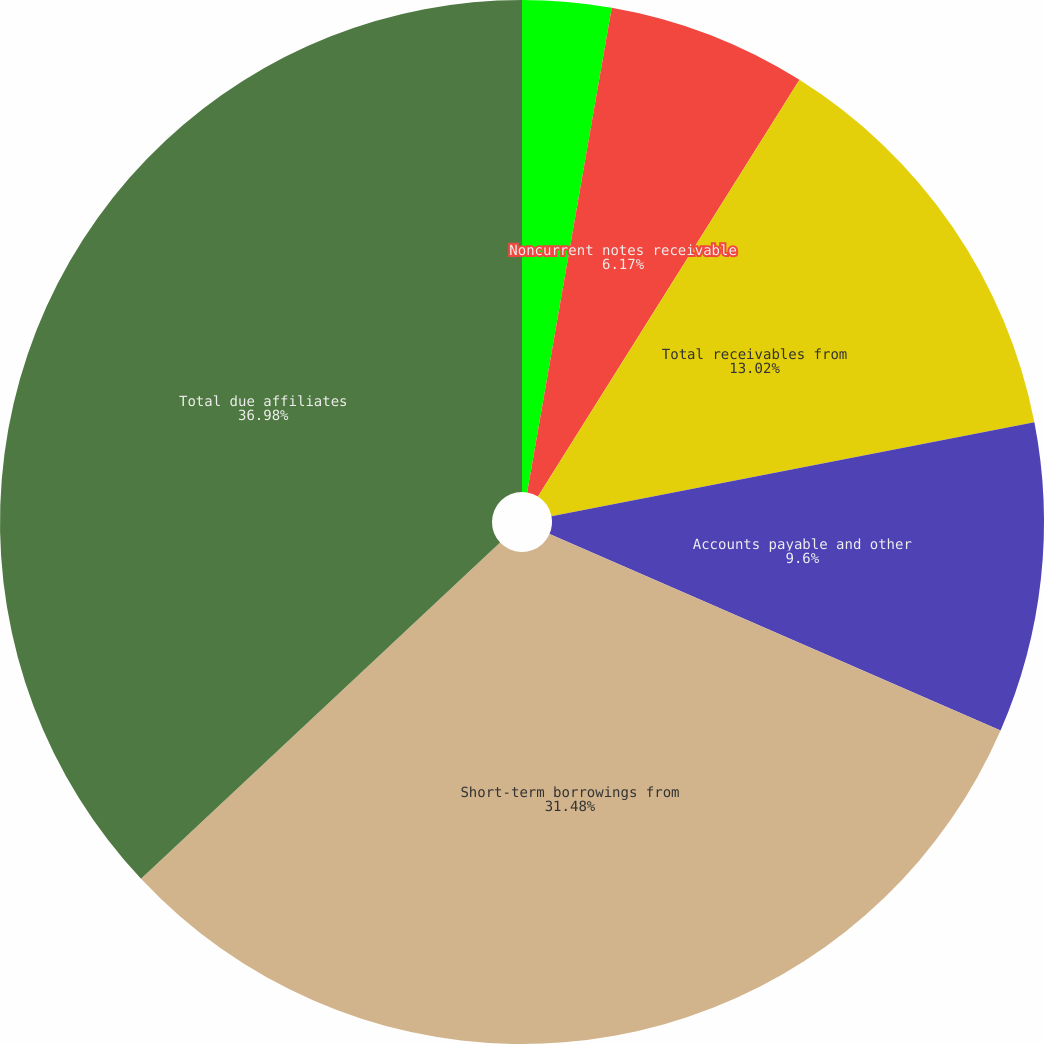Convert chart. <chart><loc_0><loc_0><loc_500><loc_500><pie_chart><fcel>Current notes receivable<fcel>Noncurrent notes receivable<fcel>Total receivables from<fcel>Accounts payable and other<fcel>Short-term borrowings from<fcel>Total due affiliates<nl><fcel>2.75%<fcel>6.17%<fcel>13.02%<fcel>9.6%<fcel>31.48%<fcel>36.98%<nl></chart> 